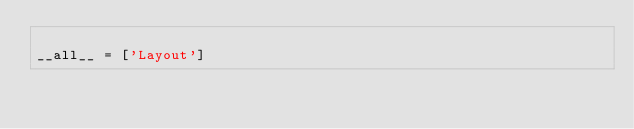<code> <loc_0><loc_0><loc_500><loc_500><_Python_>
__all__ = ['Layout']
</code> 